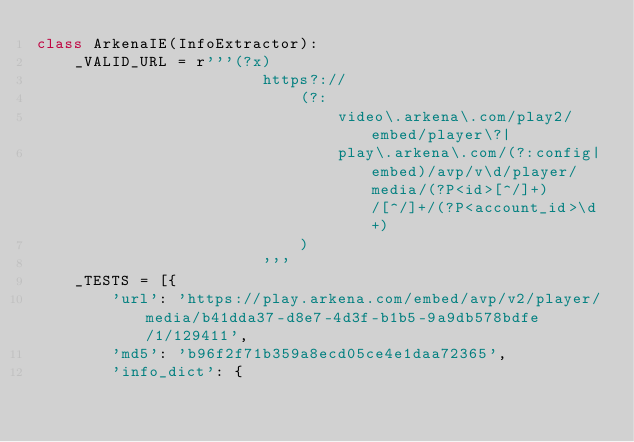Convert code to text. <code><loc_0><loc_0><loc_500><loc_500><_Python_>class ArkenaIE(InfoExtractor):
    _VALID_URL = r'''(?x)
                        https?://
                            (?:
                                video\.arkena\.com/play2/embed/player\?|
                                play\.arkena\.com/(?:config|embed)/avp/v\d/player/media/(?P<id>[^/]+)/[^/]+/(?P<account_id>\d+)
                            )
                        '''
    _TESTS = [{
        'url': 'https://play.arkena.com/embed/avp/v2/player/media/b41dda37-d8e7-4d3f-b1b5-9a9db578bdfe/1/129411',
        'md5': 'b96f2f71b359a8ecd05ce4e1daa72365',
        'info_dict': {</code> 